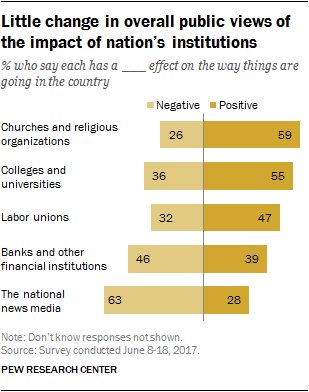Outline some significant characteristics in this image. The average value of all public views with a negative effect is approximately 40.6. The highest value of the yellow bar is 59. 